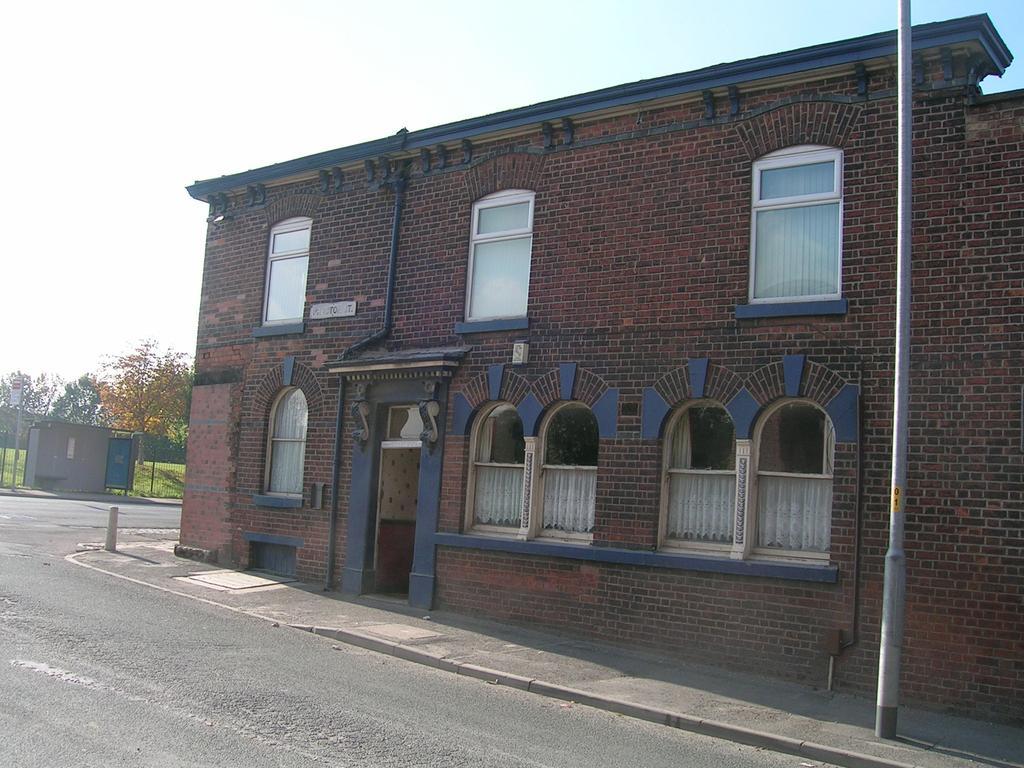How would you summarize this image in a sentence or two? In this image there is a building, in front of the building there is a pole, road, at the top there is the sky, on the left side there are trees, tent visible. 